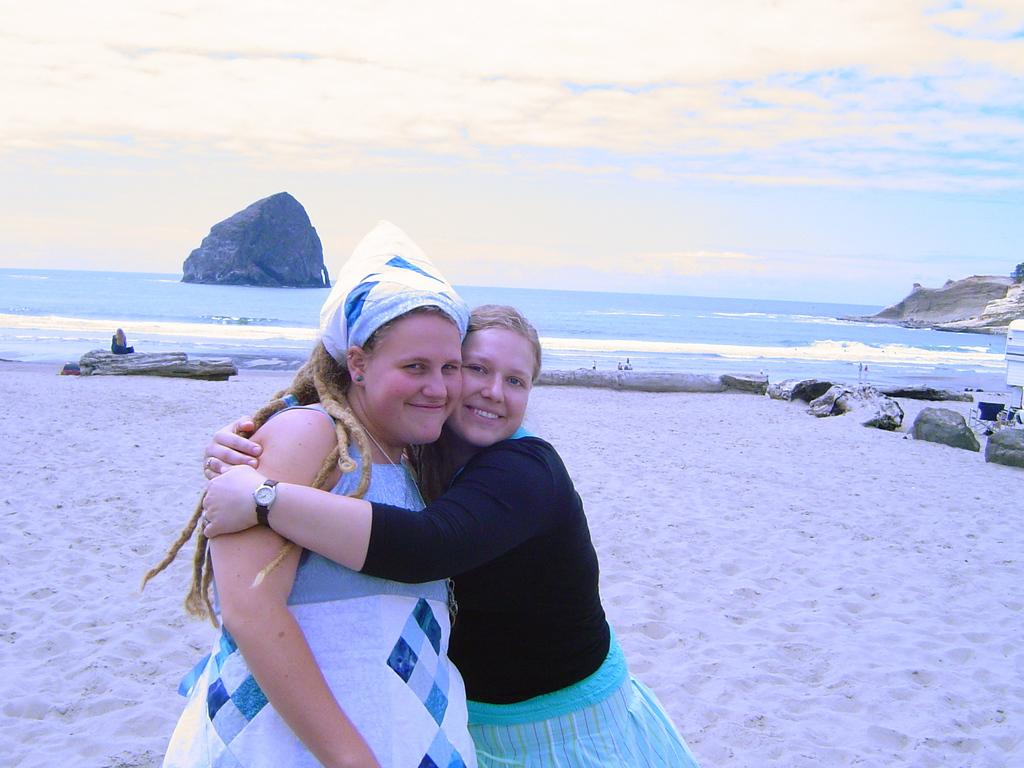How many women are in the image? There are two women in the image. What are the women doing in the image? The women are hugging each other. Where does the scene take place? The scene takes place on a beach. What can be seen in the background of the image? There is visible in the image. A: There is an ocean visible in the image, and there is a hill on the left side of the ocean. What is visible in the sky in the image? The sky is visible in the image, and clouds are present. What type of rice is being served on the tray in the image? There is no tray or rice present in the image. What type of field can be seen in the background of the image? There is no field visible in the image; it features a beach, ocean, and a hill. 